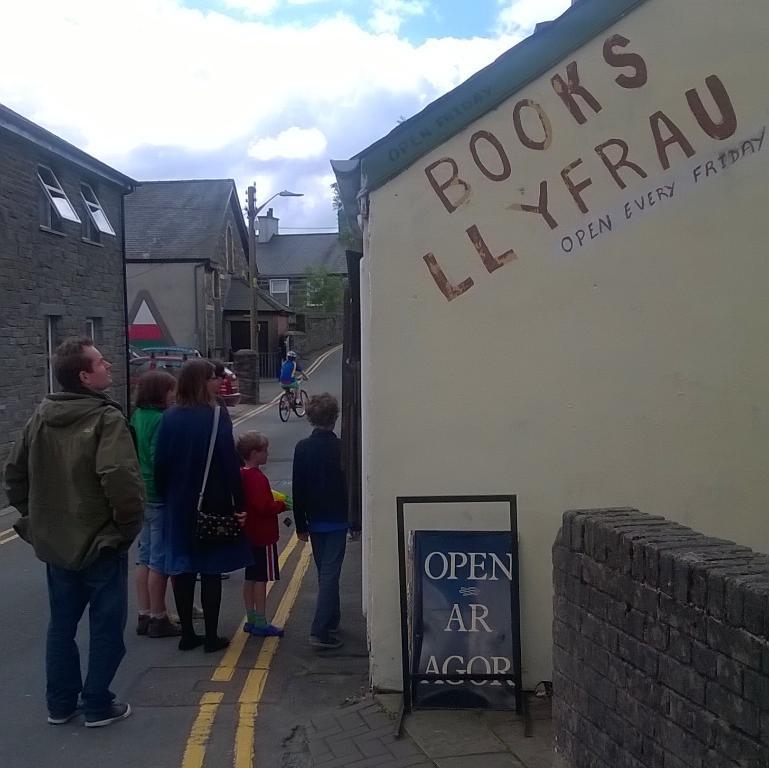How would you summarize this image in a sentence or two? In the foreground I can see a group of people are standing on the road, wall fence, buildings, light poles, tree and a person is riding a bicycle on the road. At the top I can see the sky. This image is taken may be during a day. 